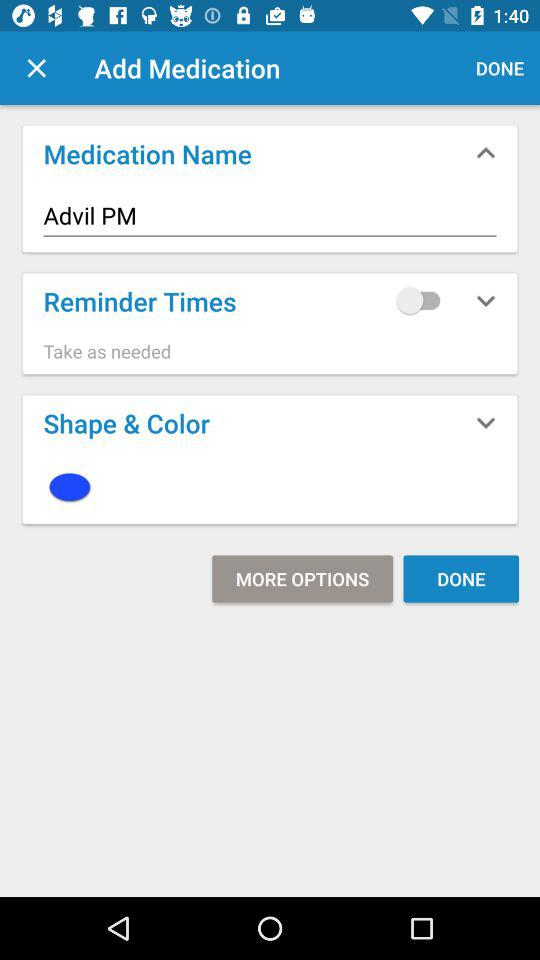What is the medication name? The medication name is Advil PM. 